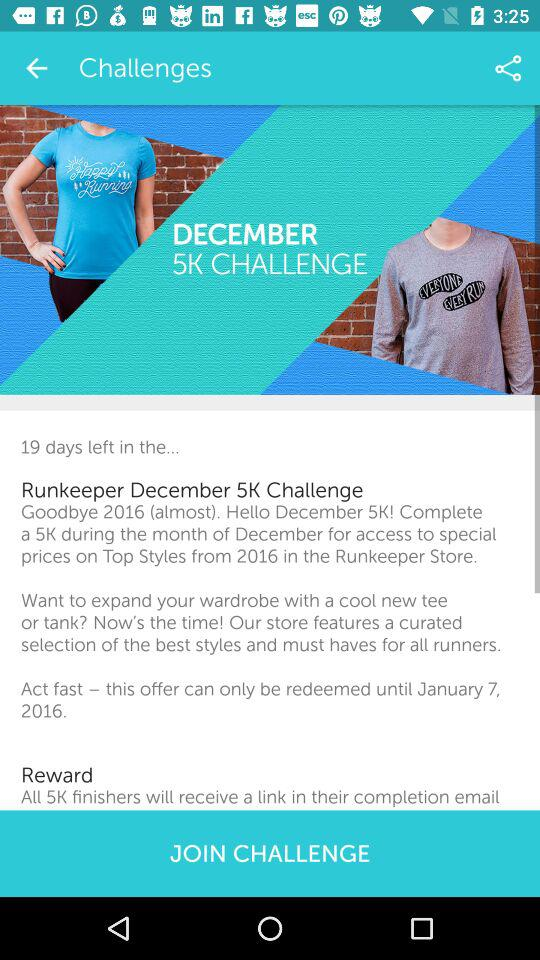What is the total number of challenges?
When the provided information is insufficient, respond with <no answer>. <no answer> 